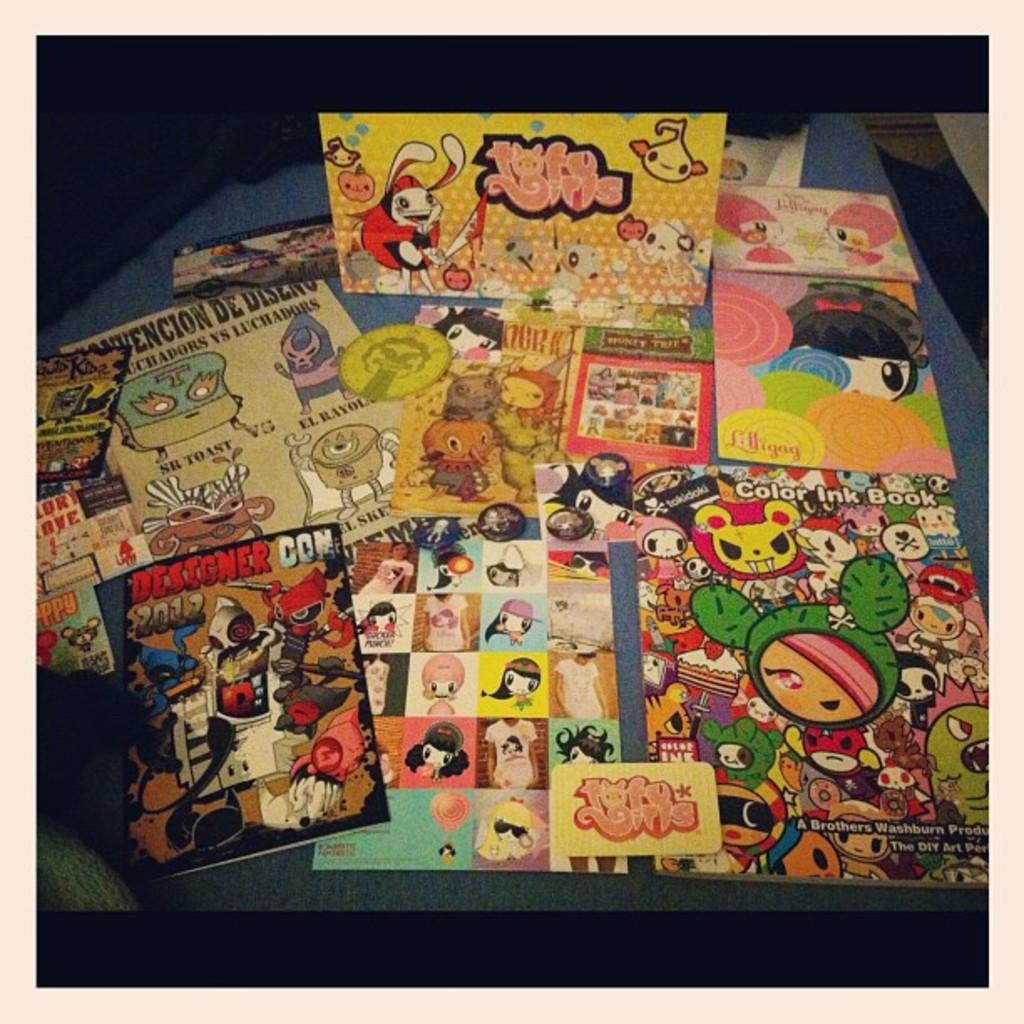Provide a one-sentence caption for the provided image. A table has a host of anime memorabilia on display from Designer Con. 